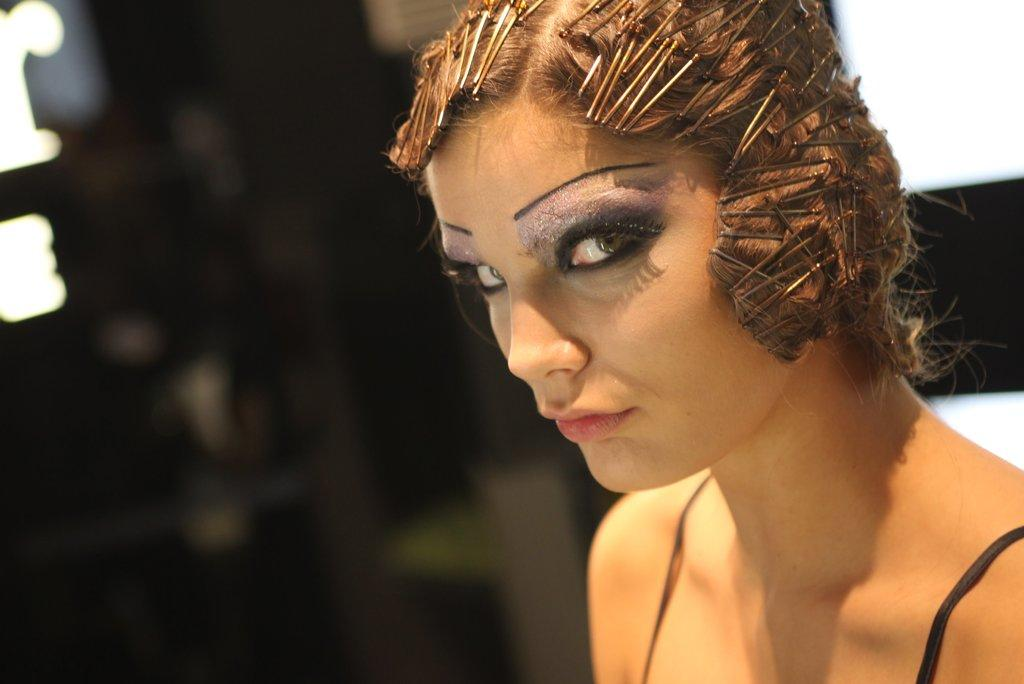What is the main subject of the image? There is a face of a person in the image. What type of club can be seen in the person's hand in the image? There is no club visible in the person's hand in the image. What kind of waste is present in the image? There is no waste present in the image; it only features the face of a person. 